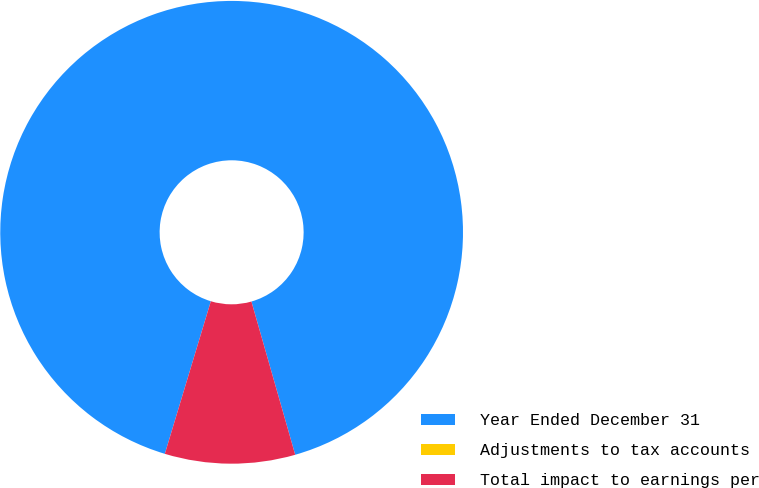Convert chart to OTSL. <chart><loc_0><loc_0><loc_500><loc_500><pie_chart><fcel>Year Ended December 31<fcel>Adjustments to tax accounts<fcel>Total impact to earnings per<nl><fcel>90.91%<fcel>0.0%<fcel>9.09%<nl></chart> 